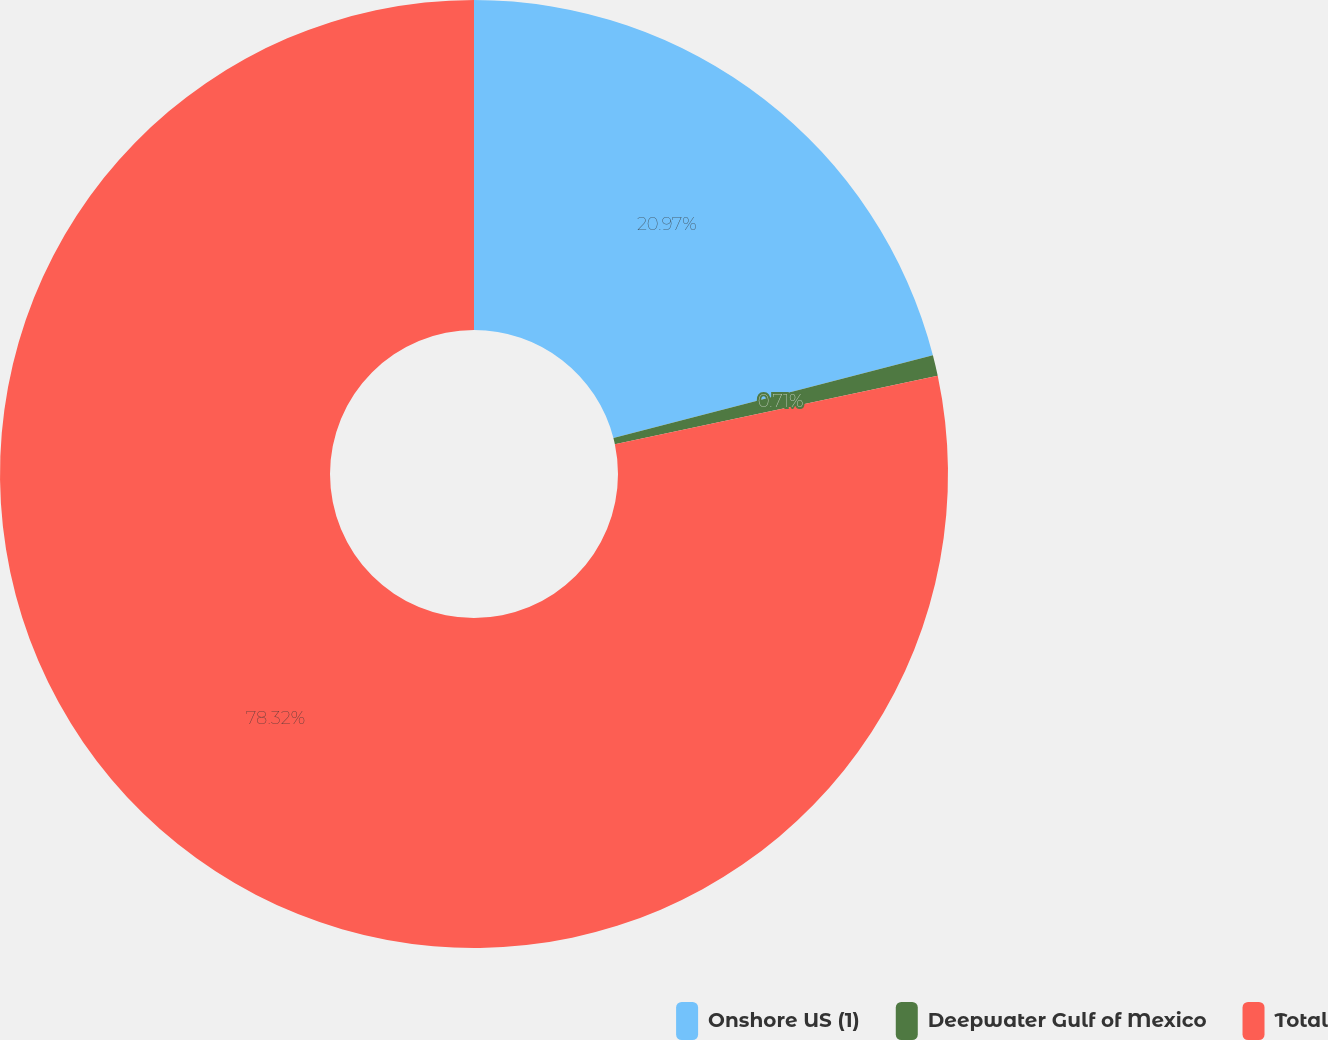<chart> <loc_0><loc_0><loc_500><loc_500><pie_chart><fcel>Onshore US (1)<fcel>Deepwater Gulf of Mexico<fcel>Total<nl><fcel>20.97%<fcel>0.71%<fcel>78.32%<nl></chart> 